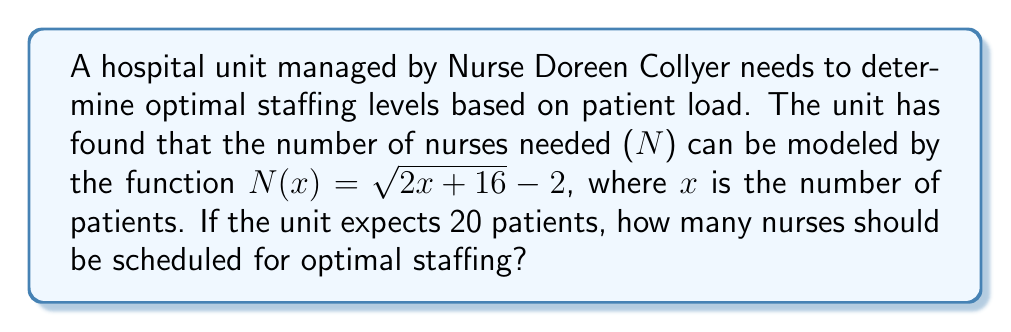Teach me how to tackle this problem. To solve this problem, we'll follow these steps:

1. Identify the given information:
   - The function for the number of nurses needed is $N(x) = \sqrt{2x + 16} - 2$
   - The expected number of patients is x = 20

2. Substitute x = 20 into the function:
   $N(20) = \sqrt{2(20) + 16} - 2$

3. Simplify the expression inside the square root:
   $N(20) = \sqrt{40 + 16} - 2$
   $N(20) = \sqrt{56} - 2$

4. Calculate the square root:
   $N(20) = 7.4833... - 2$

5. Subtract 2 from the result:
   $N(20) = 5.4833...$

6. Since we can't schedule a fractional number of nurses, we need to round up to the nearest whole number to ensure adequate staffing:
   $N(20) ≈ 6$

Therefore, the optimal staffing level for 20 patients is 6 nurses.
Answer: 6 nurses 